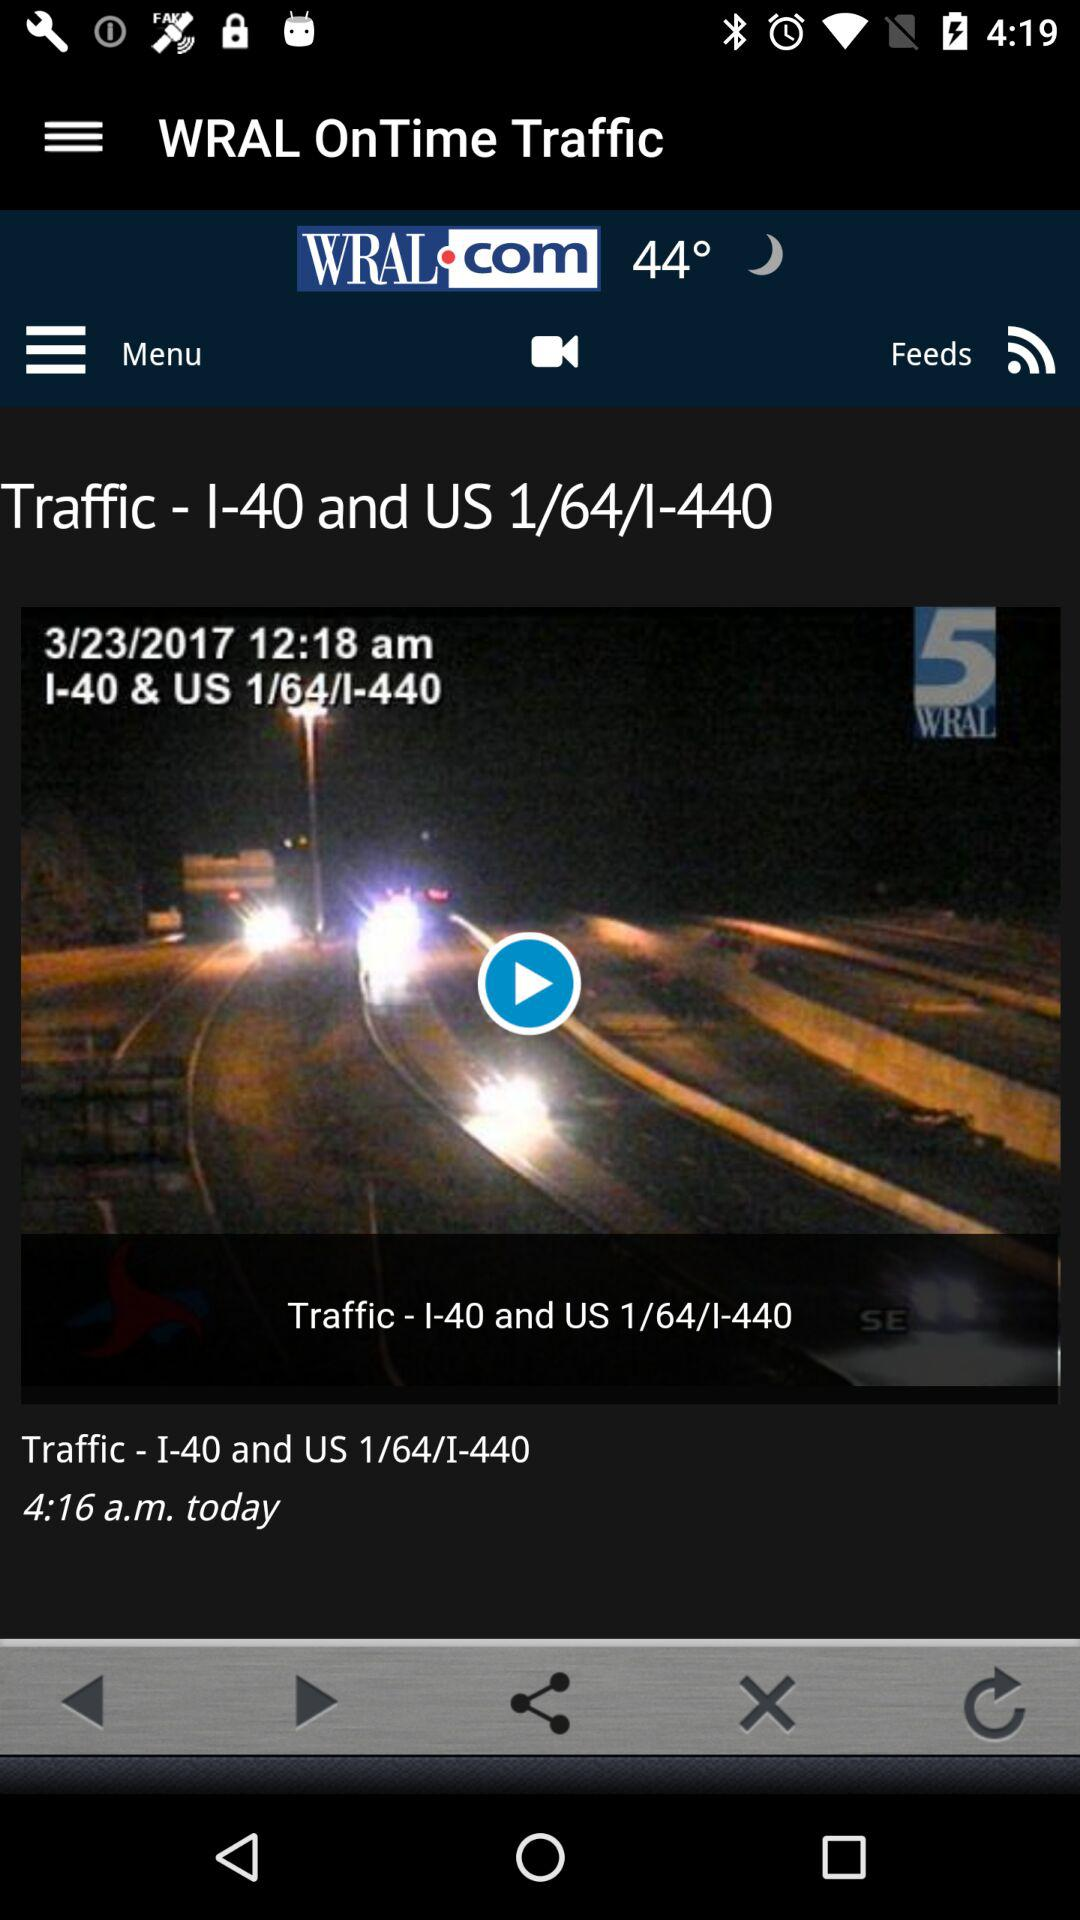What is the temperature? The temperature is 44 degrees. 